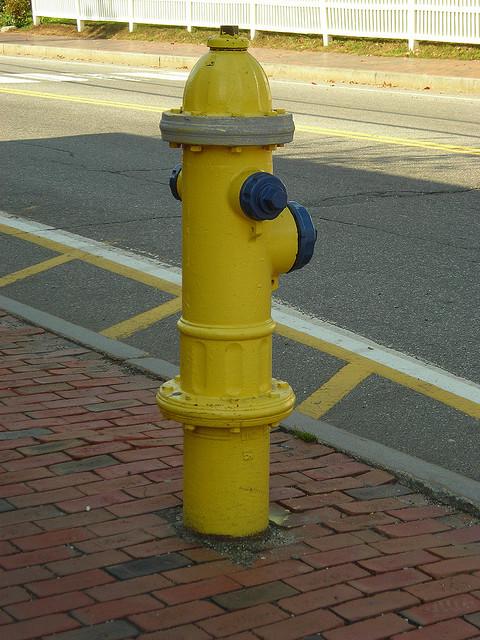What is the bottom color of the fire hydrant?
Answer briefly. Yellow. What color is the hydrant?
Short answer required. Yellow. Does the fire hydrant have rust on it?
Give a very brief answer. No. What surrounds the fire hydrant base?
Give a very brief answer. Bricks. Can the lid be opened by twisting clockwise?
Give a very brief answer. No. Is the hydrant red?
Be succinct. No. What color is the fire hydrant?
Keep it brief. Yellow. IS the fire hydrant yellow?
Answer briefly. Yes. Can you park in front of this object?
Give a very brief answer. No. How many trees are potted across the street?
Give a very brief answer. 0. What color is the edge of the sidewalk?
Concise answer only. Gray. Is the hydrant rusty?
Short answer required. No. 